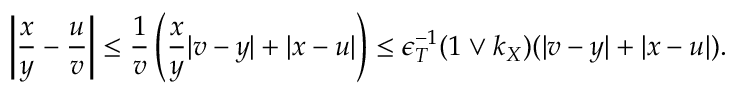<formula> <loc_0><loc_0><loc_500><loc_500>\left | \frac { x } { y } - \frac { u } { v } \right | \leq \frac { 1 } { v } \left ( \frac { x } { y } | v - y | + | x - u | \right ) \leq \epsilon _ { T } ^ { - 1 } ( 1 \vee k _ { X } ) ( | v - y | + | x - u | ) .</formula> 